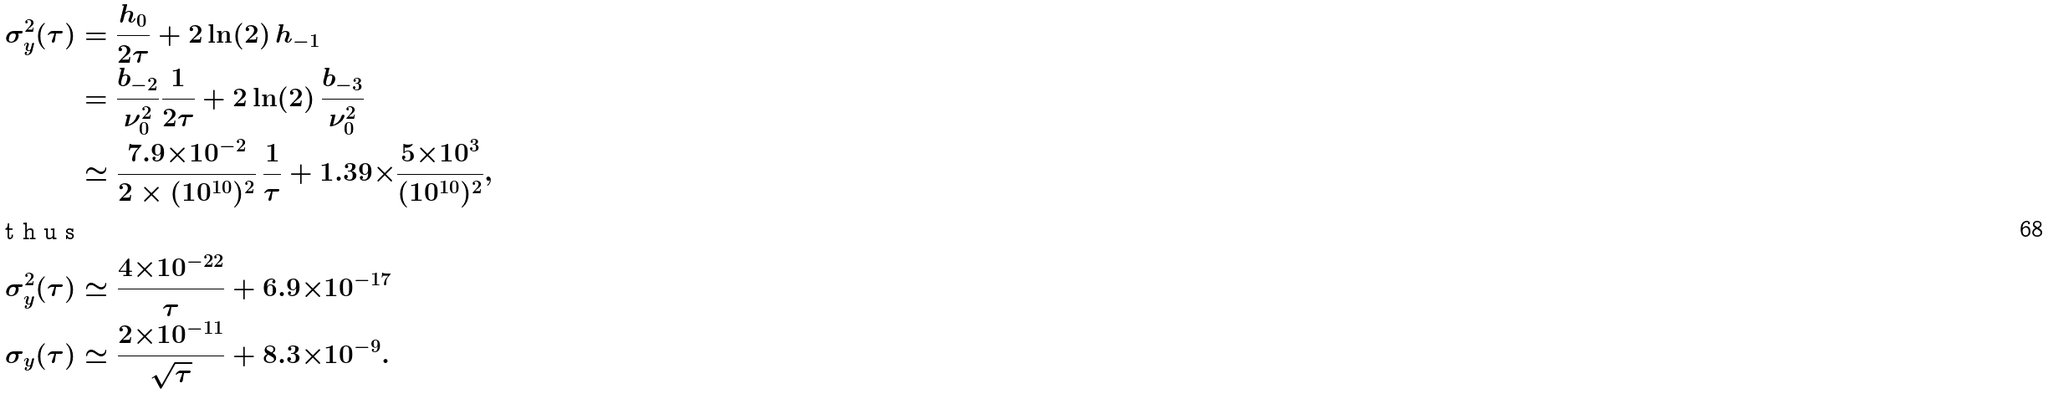<formula> <loc_0><loc_0><loc_500><loc_500>\sigma ^ { 2 } _ { y } ( \tau ) & = \frac { h _ { 0 } } { 2 \tau } + 2 \ln ( 2 ) \, h _ { - 1 } \\ & = \frac { b _ { - 2 } } { \nu _ { 0 } ^ { 2 } } \frac { 1 } { 2 \tau } + 2 \ln ( 2 ) \, \frac { b _ { - 3 } } { \nu _ { 0 } ^ { 2 } } \\ & \simeq \frac { 7 . 9 { \times } 1 0 ^ { - 2 } } { 2 \times ( 1 0 ^ { 1 0 } ) ^ { 2 } } \, \frac { 1 } { \tau } + 1 . 3 9 { \times } \frac { 5 { \times } 1 0 ^ { 3 } } { ( 1 0 ^ { 1 0 } ) ^ { 2 } } , \intertext { t h u s } \sigma ^ { 2 } _ { y } ( \tau ) & \simeq \frac { 4 { \times } 1 0 ^ { - 2 2 } } { \tau } + 6 . 9 { \times } 1 0 ^ { - 1 7 } \\ \sigma _ { y } ( \tau ) & \simeq \frac { 2 { \times } 1 0 ^ { - 1 1 } } { \sqrt { \tau } } + 8 . 3 { \times } 1 0 ^ { - 9 } .</formula> 